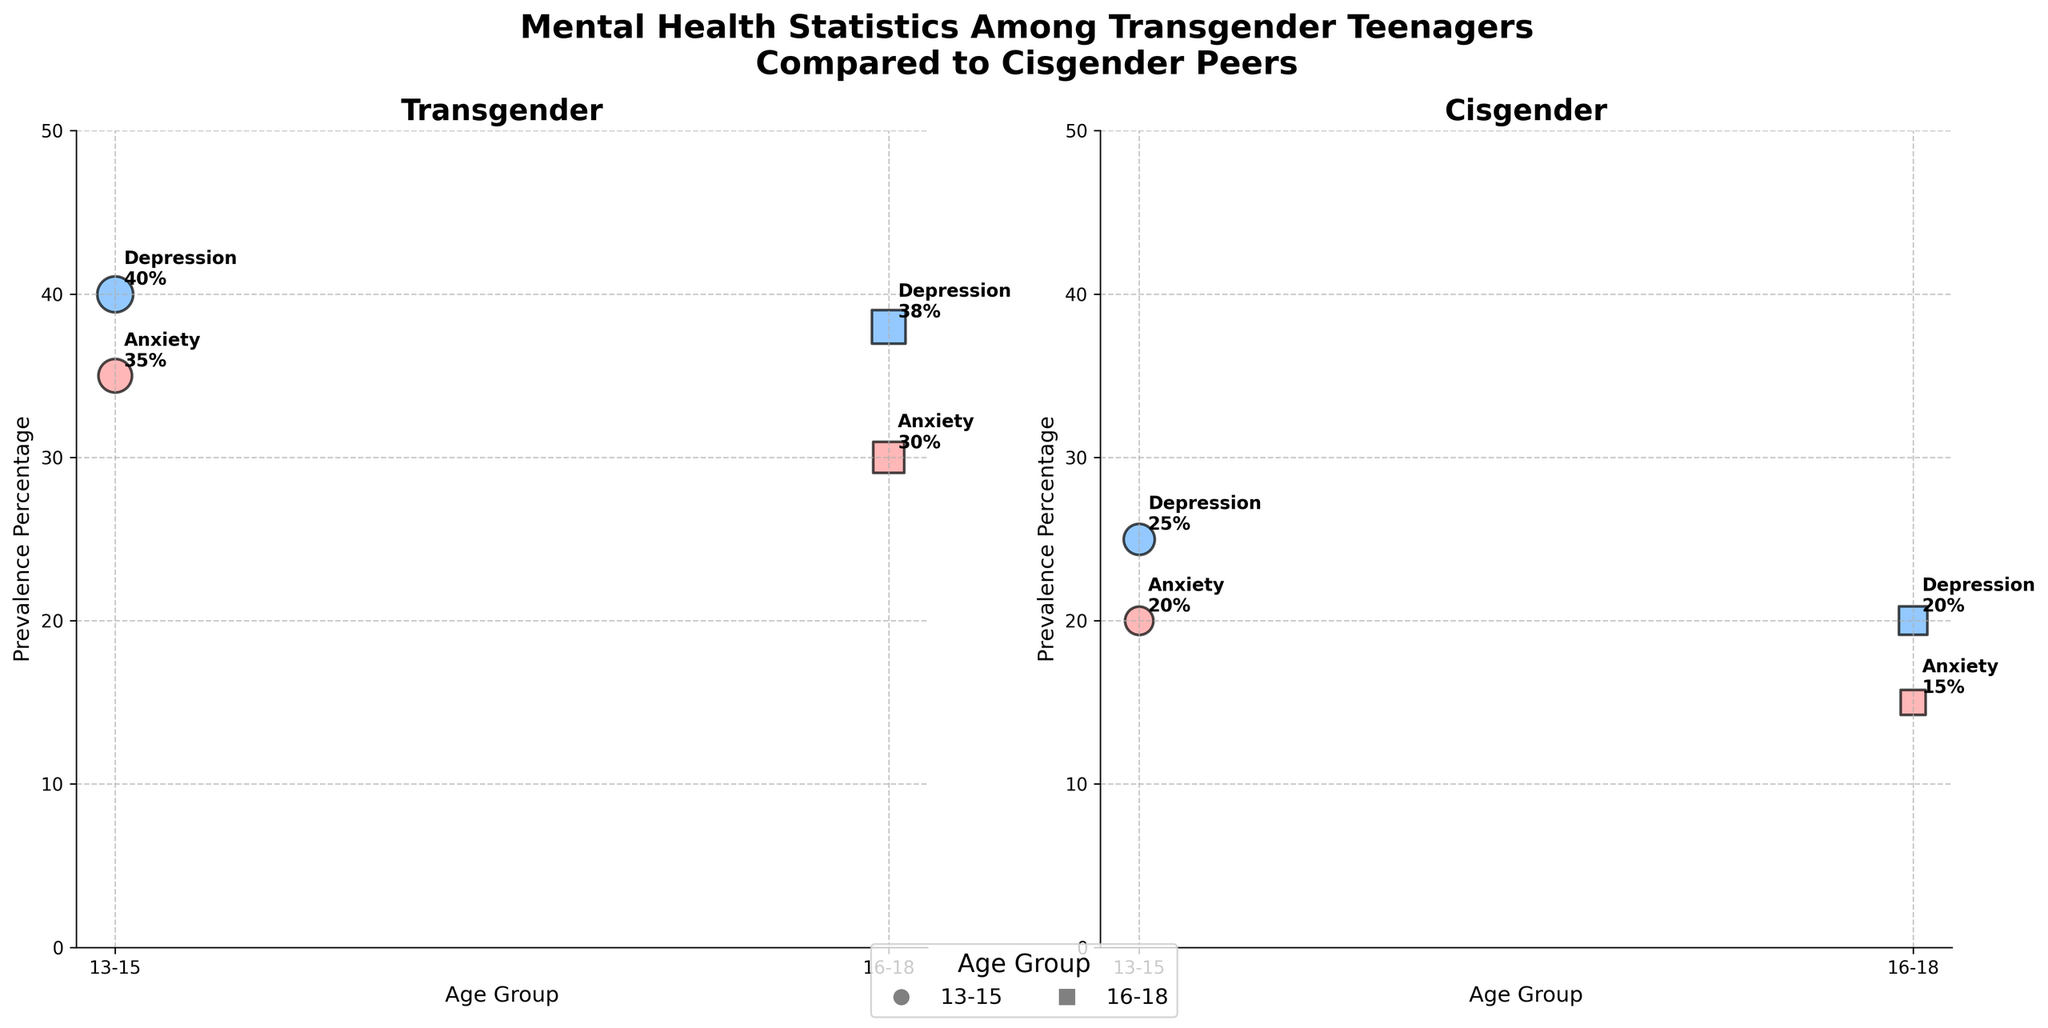What is the prevalence percentage of anxiety among transgender teenagers aged 13-15? The data point for transgender teenagers aged 13-15 with anxiety is marked with a circular bubble in the left subplot. The prevalence percentage annotated next to it is 35%.
Answer: 35% What is the severity score for depression among cisgender teenagers aged 16-18? In the right subplot, the bubble representing cisgender teenagers aged 16-18 with depression (square marker) has a size indicating a severity score of 5, as explained in the figure legend where severity score translates to bubble size.
Answer: 5 How does the prevalence of depression compare between transgender and cisgender teenagers aged 13-15? In the figure, the left subplot shows a 40% prevalence for transgender teenagers, while the right subplot shows a 25% prevalence for cisgender teenagers. This means transgender teenagers have a higher prevalence of depression.
Answer: Transgender teenagers have a higher prevalence What is the difference in severity scores for anxiety between transgender and cisgender teenagers aged 13-15? From the subplots, the severity score for transgender teenagers (13-15) is 7, and for cisgender teenagers (13-15), it is 5. The difference is 7 - 5 = 2.
Answer: 2 Which age group of transgender teenagers has a higher prevalence of anxiety? The left subplot shows two bubbles for transgender teenagers with anxiety. The bubble for ages 13-15 indicates a 35% prevalence, and for 16-18, it shows 30%. The 13-15 age group has a higher prevalence.
Answer: 13-15 What is the condition and prevalence percentage for the largest bubble in the right subplot? In the right subplot (cisgender), the largest bubble corresponds to depression in the 13-15 age group. The annotated prevalence percentage for this bubble is 25%.
Answer: Depression, 25% Compare the prevalence percentage of anxiety in transgender teenagers aged 16-18 to cisgender teenagers of the same age group. The left subplot shows a 30% prevalence for transgender teenagers aged 16-18, while the right subplot indicates a 15% prevalence for cisgender teenagers aged 16-18 with anxiety. The transgender group has a higher prevalence.
Answer: Transgender teenagers have a higher prevalence Which age group and condition correspond to the smallest bubble in the left subplot? The smallest bubble in the left subplot (transgender) has a circular marker and corresponds to anxiety in the 16-18 age group, with a severity score of 6, translating to a smaller size.
Answer: 16-18, Anxiety 